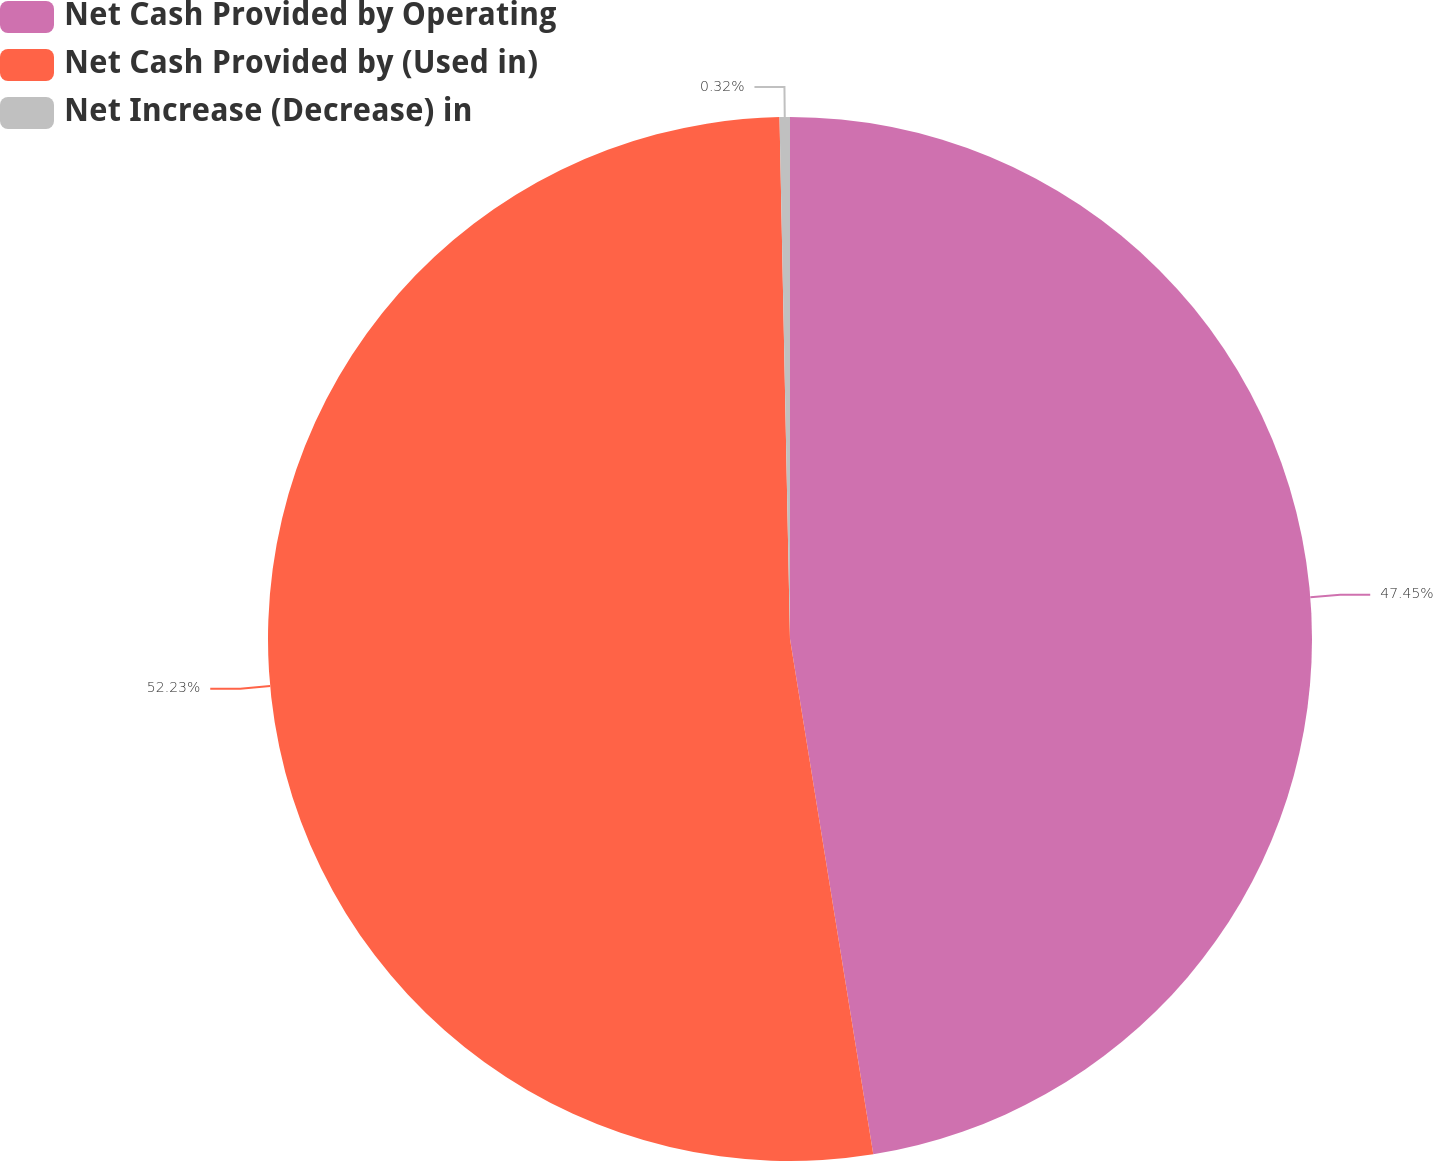<chart> <loc_0><loc_0><loc_500><loc_500><pie_chart><fcel>Net Cash Provided by Operating<fcel>Net Cash Provided by (Used in)<fcel>Net Increase (Decrease) in<nl><fcel>47.45%<fcel>52.23%<fcel>0.32%<nl></chart> 